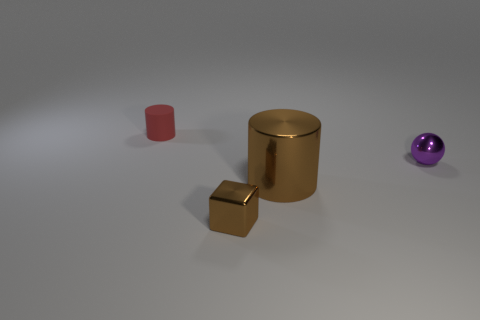Is there any other thing that is the same color as the metallic cylinder?
Your response must be concise. Yes. There is a object that is the same color as the metallic cylinder; what shape is it?
Your answer should be compact. Cube. There is a large cylinder; does it have the same color as the metal object that is in front of the large brown thing?
Provide a succinct answer. Yes. The metallic block that is the same color as the large cylinder is what size?
Your answer should be compact. Small. Does the tiny block have the same color as the shiny cylinder?
Your answer should be compact. Yes. Is there a tiny metal thing to the left of the brown shiny object that is on the right side of the small metallic thing left of the brown metal cylinder?
Your answer should be compact. Yes. What number of green spheres have the same size as the cube?
Offer a terse response. 0. Is the size of the thing in front of the big brown shiny object the same as the object behind the small purple object?
Keep it short and to the point. Yes. There is a thing that is to the left of the big shiny object and in front of the small metal ball; what is its shape?
Your response must be concise. Cube. Is there a cylinder that has the same color as the tiny metallic cube?
Give a very brief answer. Yes. 